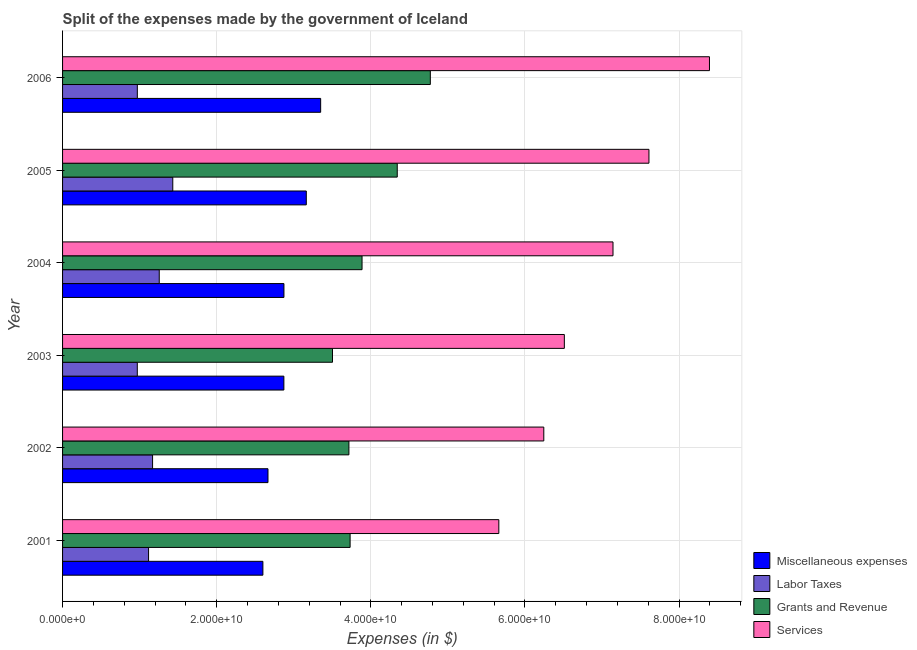How many different coloured bars are there?
Offer a terse response. 4. How many groups of bars are there?
Your answer should be compact. 6. Are the number of bars per tick equal to the number of legend labels?
Provide a succinct answer. Yes. Are the number of bars on each tick of the Y-axis equal?
Keep it short and to the point. Yes. What is the amount spent on services in 2001?
Offer a very short reply. 5.66e+1. Across all years, what is the maximum amount spent on services?
Offer a very short reply. 8.39e+1. Across all years, what is the minimum amount spent on grants and revenue?
Offer a very short reply. 3.50e+1. What is the total amount spent on labor taxes in the graph?
Your answer should be very brief. 6.91e+1. What is the difference between the amount spent on grants and revenue in 2005 and that in 2006?
Your response must be concise. -4.29e+09. What is the difference between the amount spent on miscellaneous expenses in 2004 and the amount spent on labor taxes in 2005?
Your response must be concise. 1.44e+1. What is the average amount spent on services per year?
Give a very brief answer. 6.93e+1. In the year 2002, what is the difference between the amount spent on services and amount spent on labor taxes?
Make the answer very short. 5.08e+1. In how many years, is the amount spent on services greater than 20000000000 $?
Your answer should be very brief. 6. What is the ratio of the amount spent on miscellaneous expenses in 2001 to that in 2002?
Provide a succinct answer. 0.97. Is the amount spent on services in 2002 less than that in 2006?
Make the answer very short. Yes. Is the difference between the amount spent on labor taxes in 2002 and 2003 greater than the difference between the amount spent on miscellaneous expenses in 2002 and 2003?
Your answer should be very brief. Yes. What is the difference between the highest and the second highest amount spent on miscellaneous expenses?
Make the answer very short. 1.86e+09. What is the difference between the highest and the lowest amount spent on miscellaneous expenses?
Your answer should be very brief. 7.50e+09. In how many years, is the amount spent on miscellaneous expenses greater than the average amount spent on miscellaneous expenses taken over all years?
Offer a terse response. 2. Is it the case that in every year, the sum of the amount spent on miscellaneous expenses and amount spent on labor taxes is greater than the sum of amount spent on services and amount spent on grants and revenue?
Provide a succinct answer. No. What does the 2nd bar from the top in 2006 represents?
Your answer should be very brief. Grants and Revenue. What does the 4th bar from the bottom in 2004 represents?
Offer a terse response. Services. Is it the case that in every year, the sum of the amount spent on miscellaneous expenses and amount spent on labor taxes is greater than the amount spent on grants and revenue?
Your answer should be very brief. No. How many bars are there?
Ensure brevity in your answer.  24. What is the difference between two consecutive major ticks on the X-axis?
Offer a terse response. 2.00e+1. Are the values on the major ticks of X-axis written in scientific E-notation?
Provide a succinct answer. Yes. Does the graph contain grids?
Offer a very short reply. Yes. Where does the legend appear in the graph?
Provide a short and direct response. Bottom right. How many legend labels are there?
Give a very brief answer. 4. How are the legend labels stacked?
Keep it short and to the point. Vertical. What is the title of the graph?
Your response must be concise. Split of the expenses made by the government of Iceland. Does "Secondary" appear as one of the legend labels in the graph?
Provide a succinct answer. No. What is the label or title of the X-axis?
Offer a terse response. Expenses (in $). What is the Expenses (in $) in Miscellaneous expenses in 2001?
Keep it short and to the point. 2.60e+1. What is the Expenses (in $) in Labor Taxes in 2001?
Give a very brief answer. 1.12e+1. What is the Expenses (in $) of Grants and Revenue in 2001?
Offer a very short reply. 3.73e+1. What is the Expenses (in $) in Services in 2001?
Make the answer very short. 5.66e+1. What is the Expenses (in $) of Miscellaneous expenses in 2002?
Your answer should be compact. 2.67e+1. What is the Expenses (in $) of Labor Taxes in 2002?
Keep it short and to the point. 1.17e+1. What is the Expenses (in $) of Grants and Revenue in 2002?
Your answer should be compact. 3.72e+1. What is the Expenses (in $) of Services in 2002?
Ensure brevity in your answer.  6.24e+1. What is the Expenses (in $) of Miscellaneous expenses in 2003?
Provide a short and direct response. 2.87e+1. What is the Expenses (in $) of Labor Taxes in 2003?
Your answer should be compact. 9.70e+09. What is the Expenses (in $) of Grants and Revenue in 2003?
Provide a succinct answer. 3.50e+1. What is the Expenses (in $) of Services in 2003?
Keep it short and to the point. 6.51e+1. What is the Expenses (in $) of Miscellaneous expenses in 2004?
Your answer should be very brief. 2.87e+1. What is the Expenses (in $) in Labor Taxes in 2004?
Your response must be concise. 1.25e+1. What is the Expenses (in $) in Grants and Revenue in 2004?
Make the answer very short. 3.89e+1. What is the Expenses (in $) of Services in 2004?
Give a very brief answer. 7.14e+1. What is the Expenses (in $) in Miscellaneous expenses in 2005?
Provide a succinct answer. 3.16e+1. What is the Expenses (in $) of Labor Taxes in 2005?
Ensure brevity in your answer.  1.43e+1. What is the Expenses (in $) in Grants and Revenue in 2005?
Keep it short and to the point. 4.34e+1. What is the Expenses (in $) of Services in 2005?
Make the answer very short. 7.61e+1. What is the Expenses (in $) of Miscellaneous expenses in 2006?
Provide a succinct answer. 3.35e+1. What is the Expenses (in $) of Labor Taxes in 2006?
Your answer should be very brief. 9.70e+09. What is the Expenses (in $) of Grants and Revenue in 2006?
Offer a terse response. 4.77e+1. What is the Expenses (in $) of Services in 2006?
Ensure brevity in your answer.  8.39e+1. Across all years, what is the maximum Expenses (in $) of Miscellaneous expenses?
Offer a very short reply. 3.35e+1. Across all years, what is the maximum Expenses (in $) in Labor Taxes?
Give a very brief answer. 1.43e+1. Across all years, what is the maximum Expenses (in $) of Grants and Revenue?
Provide a short and direct response. 4.77e+1. Across all years, what is the maximum Expenses (in $) in Services?
Your response must be concise. 8.39e+1. Across all years, what is the minimum Expenses (in $) of Miscellaneous expenses?
Make the answer very short. 2.60e+1. Across all years, what is the minimum Expenses (in $) in Labor Taxes?
Offer a very short reply. 9.70e+09. Across all years, what is the minimum Expenses (in $) in Grants and Revenue?
Your response must be concise. 3.50e+1. Across all years, what is the minimum Expenses (in $) in Services?
Offer a very short reply. 5.66e+1. What is the total Expenses (in $) of Miscellaneous expenses in the graph?
Your response must be concise. 1.75e+11. What is the total Expenses (in $) of Labor Taxes in the graph?
Provide a short and direct response. 6.91e+1. What is the total Expenses (in $) of Grants and Revenue in the graph?
Make the answer very short. 2.40e+11. What is the total Expenses (in $) of Services in the graph?
Make the answer very short. 4.16e+11. What is the difference between the Expenses (in $) of Miscellaneous expenses in 2001 and that in 2002?
Give a very brief answer. -6.62e+08. What is the difference between the Expenses (in $) of Labor Taxes in 2001 and that in 2002?
Your answer should be very brief. -5.21e+08. What is the difference between the Expenses (in $) of Grants and Revenue in 2001 and that in 2002?
Offer a terse response. 1.56e+08. What is the difference between the Expenses (in $) in Services in 2001 and that in 2002?
Offer a very short reply. -5.83e+09. What is the difference between the Expenses (in $) in Miscellaneous expenses in 2001 and that in 2003?
Give a very brief answer. -2.72e+09. What is the difference between the Expenses (in $) in Labor Taxes in 2001 and that in 2003?
Offer a very short reply. 1.46e+09. What is the difference between the Expenses (in $) of Grants and Revenue in 2001 and that in 2003?
Give a very brief answer. 2.28e+09. What is the difference between the Expenses (in $) of Services in 2001 and that in 2003?
Give a very brief answer. -8.50e+09. What is the difference between the Expenses (in $) of Miscellaneous expenses in 2001 and that in 2004?
Your answer should be very brief. -2.73e+09. What is the difference between the Expenses (in $) in Labor Taxes in 2001 and that in 2004?
Offer a very short reply. -1.39e+09. What is the difference between the Expenses (in $) of Grants and Revenue in 2001 and that in 2004?
Give a very brief answer. -1.55e+09. What is the difference between the Expenses (in $) in Services in 2001 and that in 2004?
Your answer should be very brief. -1.48e+1. What is the difference between the Expenses (in $) in Miscellaneous expenses in 2001 and that in 2005?
Give a very brief answer. -5.63e+09. What is the difference between the Expenses (in $) in Labor Taxes in 2001 and that in 2005?
Your response must be concise. -3.14e+09. What is the difference between the Expenses (in $) of Grants and Revenue in 2001 and that in 2005?
Your answer should be very brief. -6.12e+09. What is the difference between the Expenses (in $) in Services in 2001 and that in 2005?
Offer a very short reply. -1.95e+1. What is the difference between the Expenses (in $) of Miscellaneous expenses in 2001 and that in 2006?
Provide a succinct answer. -7.50e+09. What is the difference between the Expenses (in $) of Labor Taxes in 2001 and that in 2006?
Your answer should be compact. 1.46e+09. What is the difference between the Expenses (in $) in Grants and Revenue in 2001 and that in 2006?
Your answer should be very brief. -1.04e+1. What is the difference between the Expenses (in $) of Services in 2001 and that in 2006?
Make the answer very short. -2.73e+1. What is the difference between the Expenses (in $) of Miscellaneous expenses in 2002 and that in 2003?
Provide a succinct answer. -2.06e+09. What is the difference between the Expenses (in $) of Labor Taxes in 2002 and that in 2003?
Offer a terse response. 1.98e+09. What is the difference between the Expenses (in $) in Grants and Revenue in 2002 and that in 2003?
Your response must be concise. 2.13e+09. What is the difference between the Expenses (in $) in Services in 2002 and that in 2003?
Your answer should be very brief. -2.67e+09. What is the difference between the Expenses (in $) in Miscellaneous expenses in 2002 and that in 2004?
Make the answer very short. -2.07e+09. What is the difference between the Expenses (in $) in Labor Taxes in 2002 and that in 2004?
Your answer should be very brief. -8.65e+08. What is the difference between the Expenses (in $) in Grants and Revenue in 2002 and that in 2004?
Your response must be concise. -1.70e+09. What is the difference between the Expenses (in $) of Services in 2002 and that in 2004?
Give a very brief answer. -8.98e+09. What is the difference between the Expenses (in $) of Miscellaneous expenses in 2002 and that in 2005?
Your answer should be very brief. -4.97e+09. What is the difference between the Expenses (in $) of Labor Taxes in 2002 and that in 2005?
Your response must be concise. -2.62e+09. What is the difference between the Expenses (in $) in Grants and Revenue in 2002 and that in 2005?
Give a very brief answer. -6.27e+09. What is the difference between the Expenses (in $) of Services in 2002 and that in 2005?
Make the answer very short. -1.36e+1. What is the difference between the Expenses (in $) in Miscellaneous expenses in 2002 and that in 2006?
Your answer should be very brief. -6.84e+09. What is the difference between the Expenses (in $) in Labor Taxes in 2002 and that in 2006?
Your response must be concise. 1.98e+09. What is the difference between the Expenses (in $) of Grants and Revenue in 2002 and that in 2006?
Keep it short and to the point. -1.06e+1. What is the difference between the Expenses (in $) in Services in 2002 and that in 2006?
Ensure brevity in your answer.  -2.15e+1. What is the difference between the Expenses (in $) of Miscellaneous expenses in 2003 and that in 2004?
Give a very brief answer. -7.56e+06. What is the difference between the Expenses (in $) of Labor Taxes in 2003 and that in 2004?
Give a very brief answer. -2.85e+09. What is the difference between the Expenses (in $) in Grants and Revenue in 2003 and that in 2004?
Provide a succinct answer. -3.83e+09. What is the difference between the Expenses (in $) in Services in 2003 and that in 2004?
Offer a very short reply. -6.31e+09. What is the difference between the Expenses (in $) of Miscellaneous expenses in 2003 and that in 2005?
Make the answer very short. -2.91e+09. What is the difference between the Expenses (in $) of Labor Taxes in 2003 and that in 2005?
Offer a very short reply. -4.60e+09. What is the difference between the Expenses (in $) in Grants and Revenue in 2003 and that in 2005?
Keep it short and to the point. -8.40e+09. What is the difference between the Expenses (in $) in Services in 2003 and that in 2005?
Offer a very short reply. -1.10e+1. What is the difference between the Expenses (in $) in Miscellaneous expenses in 2003 and that in 2006?
Ensure brevity in your answer.  -4.77e+09. What is the difference between the Expenses (in $) in Labor Taxes in 2003 and that in 2006?
Give a very brief answer. -5.36e+06. What is the difference between the Expenses (in $) in Grants and Revenue in 2003 and that in 2006?
Make the answer very short. -1.27e+1. What is the difference between the Expenses (in $) of Services in 2003 and that in 2006?
Offer a very short reply. -1.88e+1. What is the difference between the Expenses (in $) of Miscellaneous expenses in 2004 and that in 2005?
Your answer should be compact. -2.90e+09. What is the difference between the Expenses (in $) in Labor Taxes in 2004 and that in 2005?
Provide a short and direct response. -1.76e+09. What is the difference between the Expenses (in $) of Grants and Revenue in 2004 and that in 2005?
Give a very brief answer. -4.57e+09. What is the difference between the Expenses (in $) of Services in 2004 and that in 2005?
Your response must be concise. -4.66e+09. What is the difference between the Expenses (in $) in Miscellaneous expenses in 2004 and that in 2006?
Ensure brevity in your answer.  -4.77e+09. What is the difference between the Expenses (in $) in Labor Taxes in 2004 and that in 2006?
Offer a very short reply. 2.84e+09. What is the difference between the Expenses (in $) in Grants and Revenue in 2004 and that in 2006?
Keep it short and to the point. -8.86e+09. What is the difference between the Expenses (in $) of Services in 2004 and that in 2006?
Your answer should be very brief. -1.25e+1. What is the difference between the Expenses (in $) of Miscellaneous expenses in 2005 and that in 2006?
Keep it short and to the point. -1.86e+09. What is the difference between the Expenses (in $) of Labor Taxes in 2005 and that in 2006?
Your answer should be very brief. 4.60e+09. What is the difference between the Expenses (in $) in Grants and Revenue in 2005 and that in 2006?
Provide a succinct answer. -4.29e+09. What is the difference between the Expenses (in $) of Services in 2005 and that in 2006?
Offer a terse response. -7.85e+09. What is the difference between the Expenses (in $) of Miscellaneous expenses in 2001 and the Expenses (in $) of Labor Taxes in 2002?
Provide a short and direct response. 1.43e+1. What is the difference between the Expenses (in $) in Miscellaneous expenses in 2001 and the Expenses (in $) in Grants and Revenue in 2002?
Provide a short and direct response. -1.12e+1. What is the difference between the Expenses (in $) of Miscellaneous expenses in 2001 and the Expenses (in $) of Services in 2002?
Offer a very short reply. -3.65e+1. What is the difference between the Expenses (in $) of Labor Taxes in 2001 and the Expenses (in $) of Grants and Revenue in 2002?
Offer a very short reply. -2.60e+1. What is the difference between the Expenses (in $) in Labor Taxes in 2001 and the Expenses (in $) in Services in 2002?
Make the answer very short. -5.13e+1. What is the difference between the Expenses (in $) in Grants and Revenue in 2001 and the Expenses (in $) in Services in 2002?
Your answer should be compact. -2.51e+1. What is the difference between the Expenses (in $) of Miscellaneous expenses in 2001 and the Expenses (in $) of Labor Taxes in 2003?
Make the answer very short. 1.63e+1. What is the difference between the Expenses (in $) of Miscellaneous expenses in 2001 and the Expenses (in $) of Grants and Revenue in 2003?
Offer a terse response. -9.03e+09. What is the difference between the Expenses (in $) of Miscellaneous expenses in 2001 and the Expenses (in $) of Services in 2003?
Your response must be concise. -3.91e+1. What is the difference between the Expenses (in $) in Labor Taxes in 2001 and the Expenses (in $) in Grants and Revenue in 2003?
Provide a short and direct response. -2.39e+1. What is the difference between the Expenses (in $) in Labor Taxes in 2001 and the Expenses (in $) in Services in 2003?
Offer a terse response. -5.40e+1. What is the difference between the Expenses (in $) of Grants and Revenue in 2001 and the Expenses (in $) of Services in 2003?
Provide a succinct answer. -2.78e+1. What is the difference between the Expenses (in $) in Miscellaneous expenses in 2001 and the Expenses (in $) in Labor Taxes in 2004?
Provide a short and direct response. 1.34e+1. What is the difference between the Expenses (in $) of Miscellaneous expenses in 2001 and the Expenses (in $) of Grants and Revenue in 2004?
Keep it short and to the point. -1.29e+1. What is the difference between the Expenses (in $) in Miscellaneous expenses in 2001 and the Expenses (in $) in Services in 2004?
Your answer should be compact. -4.54e+1. What is the difference between the Expenses (in $) in Labor Taxes in 2001 and the Expenses (in $) in Grants and Revenue in 2004?
Make the answer very short. -2.77e+1. What is the difference between the Expenses (in $) in Labor Taxes in 2001 and the Expenses (in $) in Services in 2004?
Offer a terse response. -6.03e+1. What is the difference between the Expenses (in $) of Grants and Revenue in 2001 and the Expenses (in $) of Services in 2004?
Offer a very short reply. -3.41e+1. What is the difference between the Expenses (in $) in Miscellaneous expenses in 2001 and the Expenses (in $) in Labor Taxes in 2005?
Offer a terse response. 1.17e+1. What is the difference between the Expenses (in $) of Miscellaneous expenses in 2001 and the Expenses (in $) of Grants and Revenue in 2005?
Keep it short and to the point. -1.74e+1. What is the difference between the Expenses (in $) of Miscellaneous expenses in 2001 and the Expenses (in $) of Services in 2005?
Give a very brief answer. -5.01e+1. What is the difference between the Expenses (in $) of Labor Taxes in 2001 and the Expenses (in $) of Grants and Revenue in 2005?
Your response must be concise. -3.23e+1. What is the difference between the Expenses (in $) in Labor Taxes in 2001 and the Expenses (in $) in Services in 2005?
Offer a very short reply. -6.49e+1. What is the difference between the Expenses (in $) of Grants and Revenue in 2001 and the Expenses (in $) of Services in 2005?
Keep it short and to the point. -3.88e+1. What is the difference between the Expenses (in $) in Miscellaneous expenses in 2001 and the Expenses (in $) in Labor Taxes in 2006?
Offer a very short reply. 1.63e+1. What is the difference between the Expenses (in $) of Miscellaneous expenses in 2001 and the Expenses (in $) of Grants and Revenue in 2006?
Give a very brief answer. -2.17e+1. What is the difference between the Expenses (in $) in Miscellaneous expenses in 2001 and the Expenses (in $) in Services in 2006?
Give a very brief answer. -5.79e+1. What is the difference between the Expenses (in $) of Labor Taxes in 2001 and the Expenses (in $) of Grants and Revenue in 2006?
Ensure brevity in your answer.  -3.66e+1. What is the difference between the Expenses (in $) of Labor Taxes in 2001 and the Expenses (in $) of Services in 2006?
Offer a terse response. -7.28e+1. What is the difference between the Expenses (in $) of Grants and Revenue in 2001 and the Expenses (in $) of Services in 2006?
Offer a terse response. -4.66e+1. What is the difference between the Expenses (in $) of Miscellaneous expenses in 2002 and the Expenses (in $) of Labor Taxes in 2003?
Your answer should be compact. 1.70e+1. What is the difference between the Expenses (in $) of Miscellaneous expenses in 2002 and the Expenses (in $) of Grants and Revenue in 2003?
Provide a succinct answer. -8.37e+09. What is the difference between the Expenses (in $) in Miscellaneous expenses in 2002 and the Expenses (in $) in Services in 2003?
Ensure brevity in your answer.  -3.85e+1. What is the difference between the Expenses (in $) of Labor Taxes in 2002 and the Expenses (in $) of Grants and Revenue in 2003?
Your answer should be very brief. -2.33e+1. What is the difference between the Expenses (in $) in Labor Taxes in 2002 and the Expenses (in $) in Services in 2003?
Your response must be concise. -5.34e+1. What is the difference between the Expenses (in $) of Grants and Revenue in 2002 and the Expenses (in $) of Services in 2003?
Your answer should be compact. -2.80e+1. What is the difference between the Expenses (in $) in Miscellaneous expenses in 2002 and the Expenses (in $) in Labor Taxes in 2004?
Make the answer very short. 1.41e+1. What is the difference between the Expenses (in $) of Miscellaneous expenses in 2002 and the Expenses (in $) of Grants and Revenue in 2004?
Make the answer very short. -1.22e+1. What is the difference between the Expenses (in $) of Miscellaneous expenses in 2002 and the Expenses (in $) of Services in 2004?
Provide a short and direct response. -4.48e+1. What is the difference between the Expenses (in $) in Labor Taxes in 2002 and the Expenses (in $) in Grants and Revenue in 2004?
Your answer should be compact. -2.72e+1. What is the difference between the Expenses (in $) in Labor Taxes in 2002 and the Expenses (in $) in Services in 2004?
Offer a very short reply. -5.97e+1. What is the difference between the Expenses (in $) in Grants and Revenue in 2002 and the Expenses (in $) in Services in 2004?
Ensure brevity in your answer.  -3.43e+1. What is the difference between the Expenses (in $) of Miscellaneous expenses in 2002 and the Expenses (in $) of Labor Taxes in 2005?
Your answer should be very brief. 1.24e+1. What is the difference between the Expenses (in $) of Miscellaneous expenses in 2002 and the Expenses (in $) of Grants and Revenue in 2005?
Provide a succinct answer. -1.68e+1. What is the difference between the Expenses (in $) in Miscellaneous expenses in 2002 and the Expenses (in $) in Services in 2005?
Ensure brevity in your answer.  -4.94e+1. What is the difference between the Expenses (in $) of Labor Taxes in 2002 and the Expenses (in $) of Grants and Revenue in 2005?
Provide a short and direct response. -3.17e+1. What is the difference between the Expenses (in $) of Labor Taxes in 2002 and the Expenses (in $) of Services in 2005?
Keep it short and to the point. -6.44e+1. What is the difference between the Expenses (in $) of Grants and Revenue in 2002 and the Expenses (in $) of Services in 2005?
Make the answer very short. -3.89e+1. What is the difference between the Expenses (in $) of Miscellaneous expenses in 2002 and the Expenses (in $) of Labor Taxes in 2006?
Your response must be concise. 1.70e+1. What is the difference between the Expenses (in $) of Miscellaneous expenses in 2002 and the Expenses (in $) of Grants and Revenue in 2006?
Provide a short and direct response. -2.11e+1. What is the difference between the Expenses (in $) in Miscellaneous expenses in 2002 and the Expenses (in $) in Services in 2006?
Give a very brief answer. -5.73e+1. What is the difference between the Expenses (in $) in Labor Taxes in 2002 and the Expenses (in $) in Grants and Revenue in 2006?
Your answer should be very brief. -3.60e+1. What is the difference between the Expenses (in $) of Labor Taxes in 2002 and the Expenses (in $) of Services in 2006?
Your answer should be very brief. -7.23e+1. What is the difference between the Expenses (in $) in Grants and Revenue in 2002 and the Expenses (in $) in Services in 2006?
Ensure brevity in your answer.  -4.68e+1. What is the difference between the Expenses (in $) in Miscellaneous expenses in 2003 and the Expenses (in $) in Labor Taxes in 2004?
Give a very brief answer. 1.62e+1. What is the difference between the Expenses (in $) in Miscellaneous expenses in 2003 and the Expenses (in $) in Grants and Revenue in 2004?
Your answer should be compact. -1.01e+1. What is the difference between the Expenses (in $) of Miscellaneous expenses in 2003 and the Expenses (in $) of Services in 2004?
Offer a very short reply. -4.27e+1. What is the difference between the Expenses (in $) in Labor Taxes in 2003 and the Expenses (in $) in Grants and Revenue in 2004?
Make the answer very short. -2.92e+1. What is the difference between the Expenses (in $) of Labor Taxes in 2003 and the Expenses (in $) of Services in 2004?
Your response must be concise. -6.17e+1. What is the difference between the Expenses (in $) in Grants and Revenue in 2003 and the Expenses (in $) in Services in 2004?
Provide a short and direct response. -3.64e+1. What is the difference between the Expenses (in $) in Miscellaneous expenses in 2003 and the Expenses (in $) in Labor Taxes in 2005?
Keep it short and to the point. 1.44e+1. What is the difference between the Expenses (in $) in Miscellaneous expenses in 2003 and the Expenses (in $) in Grants and Revenue in 2005?
Provide a succinct answer. -1.47e+1. What is the difference between the Expenses (in $) of Miscellaneous expenses in 2003 and the Expenses (in $) of Services in 2005?
Your answer should be compact. -4.74e+1. What is the difference between the Expenses (in $) in Labor Taxes in 2003 and the Expenses (in $) in Grants and Revenue in 2005?
Your response must be concise. -3.37e+1. What is the difference between the Expenses (in $) of Labor Taxes in 2003 and the Expenses (in $) of Services in 2005?
Your answer should be compact. -6.64e+1. What is the difference between the Expenses (in $) in Grants and Revenue in 2003 and the Expenses (in $) in Services in 2005?
Provide a succinct answer. -4.11e+1. What is the difference between the Expenses (in $) in Miscellaneous expenses in 2003 and the Expenses (in $) in Labor Taxes in 2006?
Make the answer very short. 1.90e+1. What is the difference between the Expenses (in $) of Miscellaneous expenses in 2003 and the Expenses (in $) of Grants and Revenue in 2006?
Provide a succinct answer. -1.90e+1. What is the difference between the Expenses (in $) in Miscellaneous expenses in 2003 and the Expenses (in $) in Services in 2006?
Provide a succinct answer. -5.52e+1. What is the difference between the Expenses (in $) in Labor Taxes in 2003 and the Expenses (in $) in Grants and Revenue in 2006?
Make the answer very short. -3.80e+1. What is the difference between the Expenses (in $) in Labor Taxes in 2003 and the Expenses (in $) in Services in 2006?
Give a very brief answer. -7.42e+1. What is the difference between the Expenses (in $) of Grants and Revenue in 2003 and the Expenses (in $) of Services in 2006?
Your answer should be compact. -4.89e+1. What is the difference between the Expenses (in $) in Miscellaneous expenses in 2004 and the Expenses (in $) in Labor Taxes in 2005?
Ensure brevity in your answer.  1.44e+1. What is the difference between the Expenses (in $) in Miscellaneous expenses in 2004 and the Expenses (in $) in Grants and Revenue in 2005?
Offer a terse response. -1.47e+1. What is the difference between the Expenses (in $) in Miscellaneous expenses in 2004 and the Expenses (in $) in Services in 2005?
Make the answer very short. -4.74e+1. What is the difference between the Expenses (in $) in Labor Taxes in 2004 and the Expenses (in $) in Grants and Revenue in 2005?
Your response must be concise. -3.09e+1. What is the difference between the Expenses (in $) of Labor Taxes in 2004 and the Expenses (in $) of Services in 2005?
Make the answer very short. -6.35e+1. What is the difference between the Expenses (in $) of Grants and Revenue in 2004 and the Expenses (in $) of Services in 2005?
Provide a succinct answer. -3.72e+1. What is the difference between the Expenses (in $) in Miscellaneous expenses in 2004 and the Expenses (in $) in Labor Taxes in 2006?
Your response must be concise. 1.90e+1. What is the difference between the Expenses (in $) in Miscellaneous expenses in 2004 and the Expenses (in $) in Grants and Revenue in 2006?
Ensure brevity in your answer.  -1.90e+1. What is the difference between the Expenses (in $) of Miscellaneous expenses in 2004 and the Expenses (in $) of Services in 2006?
Provide a succinct answer. -5.52e+1. What is the difference between the Expenses (in $) of Labor Taxes in 2004 and the Expenses (in $) of Grants and Revenue in 2006?
Ensure brevity in your answer.  -3.52e+1. What is the difference between the Expenses (in $) of Labor Taxes in 2004 and the Expenses (in $) of Services in 2006?
Your response must be concise. -7.14e+1. What is the difference between the Expenses (in $) of Grants and Revenue in 2004 and the Expenses (in $) of Services in 2006?
Provide a short and direct response. -4.51e+1. What is the difference between the Expenses (in $) in Miscellaneous expenses in 2005 and the Expenses (in $) in Labor Taxes in 2006?
Offer a very short reply. 2.19e+1. What is the difference between the Expenses (in $) in Miscellaneous expenses in 2005 and the Expenses (in $) in Grants and Revenue in 2006?
Your answer should be very brief. -1.61e+1. What is the difference between the Expenses (in $) of Miscellaneous expenses in 2005 and the Expenses (in $) of Services in 2006?
Your answer should be compact. -5.23e+1. What is the difference between the Expenses (in $) in Labor Taxes in 2005 and the Expenses (in $) in Grants and Revenue in 2006?
Ensure brevity in your answer.  -3.34e+1. What is the difference between the Expenses (in $) of Labor Taxes in 2005 and the Expenses (in $) of Services in 2006?
Your answer should be compact. -6.96e+1. What is the difference between the Expenses (in $) in Grants and Revenue in 2005 and the Expenses (in $) in Services in 2006?
Offer a terse response. -4.05e+1. What is the average Expenses (in $) of Miscellaneous expenses per year?
Your answer should be very brief. 2.92e+1. What is the average Expenses (in $) in Labor Taxes per year?
Provide a succinct answer. 1.15e+1. What is the average Expenses (in $) in Grants and Revenue per year?
Give a very brief answer. 3.99e+1. What is the average Expenses (in $) of Services per year?
Keep it short and to the point. 6.93e+1. In the year 2001, what is the difference between the Expenses (in $) of Miscellaneous expenses and Expenses (in $) of Labor Taxes?
Provide a succinct answer. 1.48e+1. In the year 2001, what is the difference between the Expenses (in $) of Miscellaneous expenses and Expenses (in $) of Grants and Revenue?
Your answer should be very brief. -1.13e+1. In the year 2001, what is the difference between the Expenses (in $) in Miscellaneous expenses and Expenses (in $) in Services?
Keep it short and to the point. -3.06e+1. In the year 2001, what is the difference between the Expenses (in $) of Labor Taxes and Expenses (in $) of Grants and Revenue?
Your answer should be very brief. -2.62e+1. In the year 2001, what is the difference between the Expenses (in $) in Labor Taxes and Expenses (in $) in Services?
Your answer should be compact. -4.55e+1. In the year 2001, what is the difference between the Expenses (in $) of Grants and Revenue and Expenses (in $) of Services?
Offer a very short reply. -1.93e+1. In the year 2002, what is the difference between the Expenses (in $) of Miscellaneous expenses and Expenses (in $) of Labor Taxes?
Offer a terse response. 1.50e+1. In the year 2002, what is the difference between the Expenses (in $) in Miscellaneous expenses and Expenses (in $) in Grants and Revenue?
Keep it short and to the point. -1.05e+1. In the year 2002, what is the difference between the Expenses (in $) of Miscellaneous expenses and Expenses (in $) of Services?
Your response must be concise. -3.58e+1. In the year 2002, what is the difference between the Expenses (in $) in Labor Taxes and Expenses (in $) in Grants and Revenue?
Provide a succinct answer. -2.55e+1. In the year 2002, what is the difference between the Expenses (in $) in Labor Taxes and Expenses (in $) in Services?
Your response must be concise. -5.08e+1. In the year 2002, what is the difference between the Expenses (in $) of Grants and Revenue and Expenses (in $) of Services?
Your answer should be very brief. -2.53e+1. In the year 2003, what is the difference between the Expenses (in $) in Miscellaneous expenses and Expenses (in $) in Labor Taxes?
Your response must be concise. 1.90e+1. In the year 2003, what is the difference between the Expenses (in $) in Miscellaneous expenses and Expenses (in $) in Grants and Revenue?
Your answer should be compact. -6.31e+09. In the year 2003, what is the difference between the Expenses (in $) of Miscellaneous expenses and Expenses (in $) of Services?
Offer a very short reply. -3.64e+1. In the year 2003, what is the difference between the Expenses (in $) of Labor Taxes and Expenses (in $) of Grants and Revenue?
Make the answer very short. -2.53e+1. In the year 2003, what is the difference between the Expenses (in $) in Labor Taxes and Expenses (in $) in Services?
Offer a terse response. -5.54e+1. In the year 2003, what is the difference between the Expenses (in $) of Grants and Revenue and Expenses (in $) of Services?
Provide a short and direct response. -3.01e+1. In the year 2004, what is the difference between the Expenses (in $) in Miscellaneous expenses and Expenses (in $) in Labor Taxes?
Offer a very short reply. 1.62e+1. In the year 2004, what is the difference between the Expenses (in $) in Miscellaneous expenses and Expenses (in $) in Grants and Revenue?
Keep it short and to the point. -1.01e+1. In the year 2004, what is the difference between the Expenses (in $) in Miscellaneous expenses and Expenses (in $) in Services?
Your answer should be compact. -4.27e+1. In the year 2004, what is the difference between the Expenses (in $) in Labor Taxes and Expenses (in $) in Grants and Revenue?
Ensure brevity in your answer.  -2.63e+1. In the year 2004, what is the difference between the Expenses (in $) of Labor Taxes and Expenses (in $) of Services?
Your answer should be compact. -5.89e+1. In the year 2004, what is the difference between the Expenses (in $) in Grants and Revenue and Expenses (in $) in Services?
Your answer should be compact. -3.26e+1. In the year 2005, what is the difference between the Expenses (in $) in Miscellaneous expenses and Expenses (in $) in Labor Taxes?
Offer a very short reply. 1.73e+1. In the year 2005, what is the difference between the Expenses (in $) of Miscellaneous expenses and Expenses (in $) of Grants and Revenue?
Keep it short and to the point. -1.18e+1. In the year 2005, what is the difference between the Expenses (in $) in Miscellaneous expenses and Expenses (in $) in Services?
Keep it short and to the point. -4.45e+1. In the year 2005, what is the difference between the Expenses (in $) in Labor Taxes and Expenses (in $) in Grants and Revenue?
Provide a short and direct response. -2.91e+1. In the year 2005, what is the difference between the Expenses (in $) in Labor Taxes and Expenses (in $) in Services?
Ensure brevity in your answer.  -6.18e+1. In the year 2005, what is the difference between the Expenses (in $) of Grants and Revenue and Expenses (in $) of Services?
Ensure brevity in your answer.  -3.27e+1. In the year 2006, what is the difference between the Expenses (in $) in Miscellaneous expenses and Expenses (in $) in Labor Taxes?
Give a very brief answer. 2.38e+1. In the year 2006, what is the difference between the Expenses (in $) in Miscellaneous expenses and Expenses (in $) in Grants and Revenue?
Provide a short and direct response. -1.42e+1. In the year 2006, what is the difference between the Expenses (in $) of Miscellaneous expenses and Expenses (in $) of Services?
Your response must be concise. -5.05e+1. In the year 2006, what is the difference between the Expenses (in $) in Labor Taxes and Expenses (in $) in Grants and Revenue?
Offer a very short reply. -3.80e+1. In the year 2006, what is the difference between the Expenses (in $) in Labor Taxes and Expenses (in $) in Services?
Your answer should be compact. -7.42e+1. In the year 2006, what is the difference between the Expenses (in $) in Grants and Revenue and Expenses (in $) in Services?
Make the answer very short. -3.62e+1. What is the ratio of the Expenses (in $) in Miscellaneous expenses in 2001 to that in 2002?
Keep it short and to the point. 0.98. What is the ratio of the Expenses (in $) of Labor Taxes in 2001 to that in 2002?
Offer a very short reply. 0.96. What is the ratio of the Expenses (in $) of Services in 2001 to that in 2002?
Offer a very short reply. 0.91. What is the ratio of the Expenses (in $) of Miscellaneous expenses in 2001 to that in 2003?
Your answer should be very brief. 0.91. What is the ratio of the Expenses (in $) in Labor Taxes in 2001 to that in 2003?
Your answer should be very brief. 1.15. What is the ratio of the Expenses (in $) of Grants and Revenue in 2001 to that in 2003?
Your response must be concise. 1.07. What is the ratio of the Expenses (in $) of Services in 2001 to that in 2003?
Make the answer very short. 0.87. What is the ratio of the Expenses (in $) in Miscellaneous expenses in 2001 to that in 2004?
Give a very brief answer. 0.9. What is the ratio of the Expenses (in $) in Labor Taxes in 2001 to that in 2004?
Give a very brief answer. 0.89. What is the ratio of the Expenses (in $) in Grants and Revenue in 2001 to that in 2004?
Your response must be concise. 0.96. What is the ratio of the Expenses (in $) of Services in 2001 to that in 2004?
Give a very brief answer. 0.79. What is the ratio of the Expenses (in $) in Miscellaneous expenses in 2001 to that in 2005?
Offer a very short reply. 0.82. What is the ratio of the Expenses (in $) of Labor Taxes in 2001 to that in 2005?
Your response must be concise. 0.78. What is the ratio of the Expenses (in $) of Grants and Revenue in 2001 to that in 2005?
Your answer should be very brief. 0.86. What is the ratio of the Expenses (in $) of Services in 2001 to that in 2005?
Keep it short and to the point. 0.74. What is the ratio of the Expenses (in $) in Miscellaneous expenses in 2001 to that in 2006?
Give a very brief answer. 0.78. What is the ratio of the Expenses (in $) in Labor Taxes in 2001 to that in 2006?
Provide a short and direct response. 1.15. What is the ratio of the Expenses (in $) of Grants and Revenue in 2001 to that in 2006?
Provide a short and direct response. 0.78. What is the ratio of the Expenses (in $) in Services in 2001 to that in 2006?
Ensure brevity in your answer.  0.67. What is the ratio of the Expenses (in $) of Miscellaneous expenses in 2002 to that in 2003?
Your answer should be very brief. 0.93. What is the ratio of the Expenses (in $) of Labor Taxes in 2002 to that in 2003?
Provide a short and direct response. 1.2. What is the ratio of the Expenses (in $) in Grants and Revenue in 2002 to that in 2003?
Make the answer very short. 1.06. What is the ratio of the Expenses (in $) in Services in 2002 to that in 2003?
Provide a succinct answer. 0.96. What is the ratio of the Expenses (in $) of Miscellaneous expenses in 2002 to that in 2004?
Offer a terse response. 0.93. What is the ratio of the Expenses (in $) of Grants and Revenue in 2002 to that in 2004?
Make the answer very short. 0.96. What is the ratio of the Expenses (in $) in Services in 2002 to that in 2004?
Provide a short and direct response. 0.87. What is the ratio of the Expenses (in $) of Miscellaneous expenses in 2002 to that in 2005?
Provide a short and direct response. 0.84. What is the ratio of the Expenses (in $) in Labor Taxes in 2002 to that in 2005?
Your response must be concise. 0.82. What is the ratio of the Expenses (in $) of Grants and Revenue in 2002 to that in 2005?
Your answer should be compact. 0.86. What is the ratio of the Expenses (in $) of Services in 2002 to that in 2005?
Offer a terse response. 0.82. What is the ratio of the Expenses (in $) in Miscellaneous expenses in 2002 to that in 2006?
Offer a very short reply. 0.8. What is the ratio of the Expenses (in $) in Labor Taxes in 2002 to that in 2006?
Ensure brevity in your answer.  1.2. What is the ratio of the Expenses (in $) of Grants and Revenue in 2002 to that in 2006?
Your response must be concise. 0.78. What is the ratio of the Expenses (in $) in Services in 2002 to that in 2006?
Ensure brevity in your answer.  0.74. What is the ratio of the Expenses (in $) of Labor Taxes in 2003 to that in 2004?
Ensure brevity in your answer.  0.77. What is the ratio of the Expenses (in $) in Grants and Revenue in 2003 to that in 2004?
Offer a very short reply. 0.9. What is the ratio of the Expenses (in $) in Services in 2003 to that in 2004?
Make the answer very short. 0.91. What is the ratio of the Expenses (in $) in Miscellaneous expenses in 2003 to that in 2005?
Provide a succinct answer. 0.91. What is the ratio of the Expenses (in $) of Labor Taxes in 2003 to that in 2005?
Your response must be concise. 0.68. What is the ratio of the Expenses (in $) of Grants and Revenue in 2003 to that in 2005?
Offer a very short reply. 0.81. What is the ratio of the Expenses (in $) in Services in 2003 to that in 2005?
Ensure brevity in your answer.  0.86. What is the ratio of the Expenses (in $) in Miscellaneous expenses in 2003 to that in 2006?
Offer a terse response. 0.86. What is the ratio of the Expenses (in $) in Grants and Revenue in 2003 to that in 2006?
Keep it short and to the point. 0.73. What is the ratio of the Expenses (in $) of Services in 2003 to that in 2006?
Ensure brevity in your answer.  0.78. What is the ratio of the Expenses (in $) in Miscellaneous expenses in 2004 to that in 2005?
Offer a terse response. 0.91. What is the ratio of the Expenses (in $) of Labor Taxes in 2004 to that in 2005?
Offer a very short reply. 0.88. What is the ratio of the Expenses (in $) in Grants and Revenue in 2004 to that in 2005?
Your answer should be compact. 0.89. What is the ratio of the Expenses (in $) in Services in 2004 to that in 2005?
Your response must be concise. 0.94. What is the ratio of the Expenses (in $) of Miscellaneous expenses in 2004 to that in 2006?
Make the answer very short. 0.86. What is the ratio of the Expenses (in $) in Labor Taxes in 2004 to that in 2006?
Ensure brevity in your answer.  1.29. What is the ratio of the Expenses (in $) in Grants and Revenue in 2004 to that in 2006?
Your answer should be compact. 0.81. What is the ratio of the Expenses (in $) of Services in 2004 to that in 2006?
Your answer should be compact. 0.85. What is the ratio of the Expenses (in $) of Miscellaneous expenses in 2005 to that in 2006?
Make the answer very short. 0.94. What is the ratio of the Expenses (in $) in Labor Taxes in 2005 to that in 2006?
Offer a very short reply. 1.47. What is the ratio of the Expenses (in $) of Grants and Revenue in 2005 to that in 2006?
Offer a terse response. 0.91. What is the ratio of the Expenses (in $) in Services in 2005 to that in 2006?
Provide a succinct answer. 0.91. What is the difference between the highest and the second highest Expenses (in $) in Miscellaneous expenses?
Ensure brevity in your answer.  1.86e+09. What is the difference between the highest and the second highest Expenses (in $) of Labor Taxes?
Provide a short and direct response. 1.76e+09. What is the difference between the highest and the second highest Expenses (in $) of Grants and Revenue?
Provide a succinct answer. 4.29e+09. What is the difference between the highest and the second highest Expenses (in $) in Services?
Ensure brevity in your answer.  7.85e+09. What is the difference between the highest and the lowest Expenses (in $) of Miscellaneous expenses?
Provide a succinct answer. 7.50e+09. What is the difference between the highest and the lowest Expenses (in $) of Labor Taxes?
Your answer should be compact. 4.60e+09. What is the difference between the highest and the lowest Expenses (in $) in Grants and Revenue?
Provide a succinct answer. 1.27e+1. What is the difference between the highest and the lowest Expenses (in $) in Services?
Your answer should be very brief. 2.73e+1. 